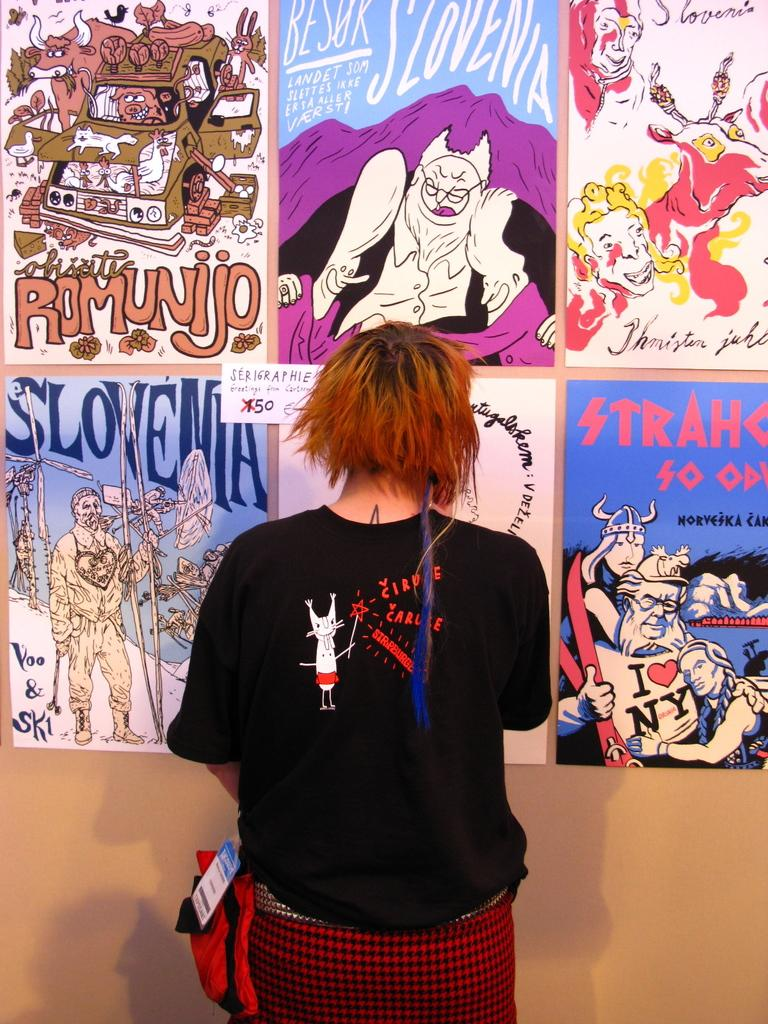<image>
Create a compact narrative representing the image presented. Girl standing in front of posters with one saying Slovenia. 